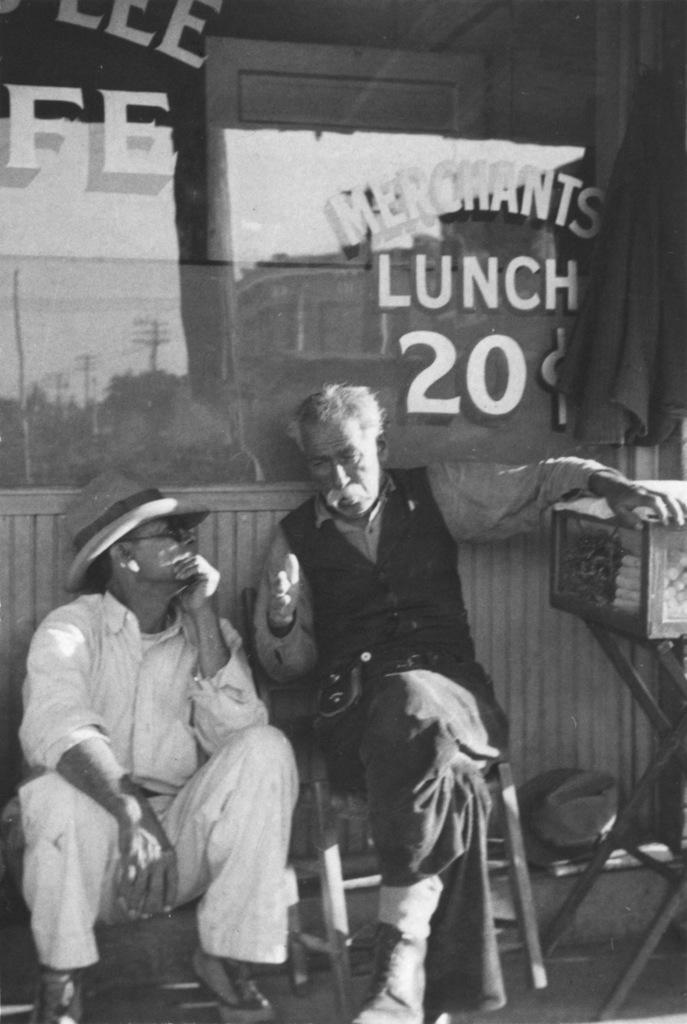Describe this image in one or two sentences. In this image there is an old man sitting on the chair on the right side. Beside her there is another man sitting on the floor. In the background there is a glass. On the right side there is a stand on which there is a wooden box. 